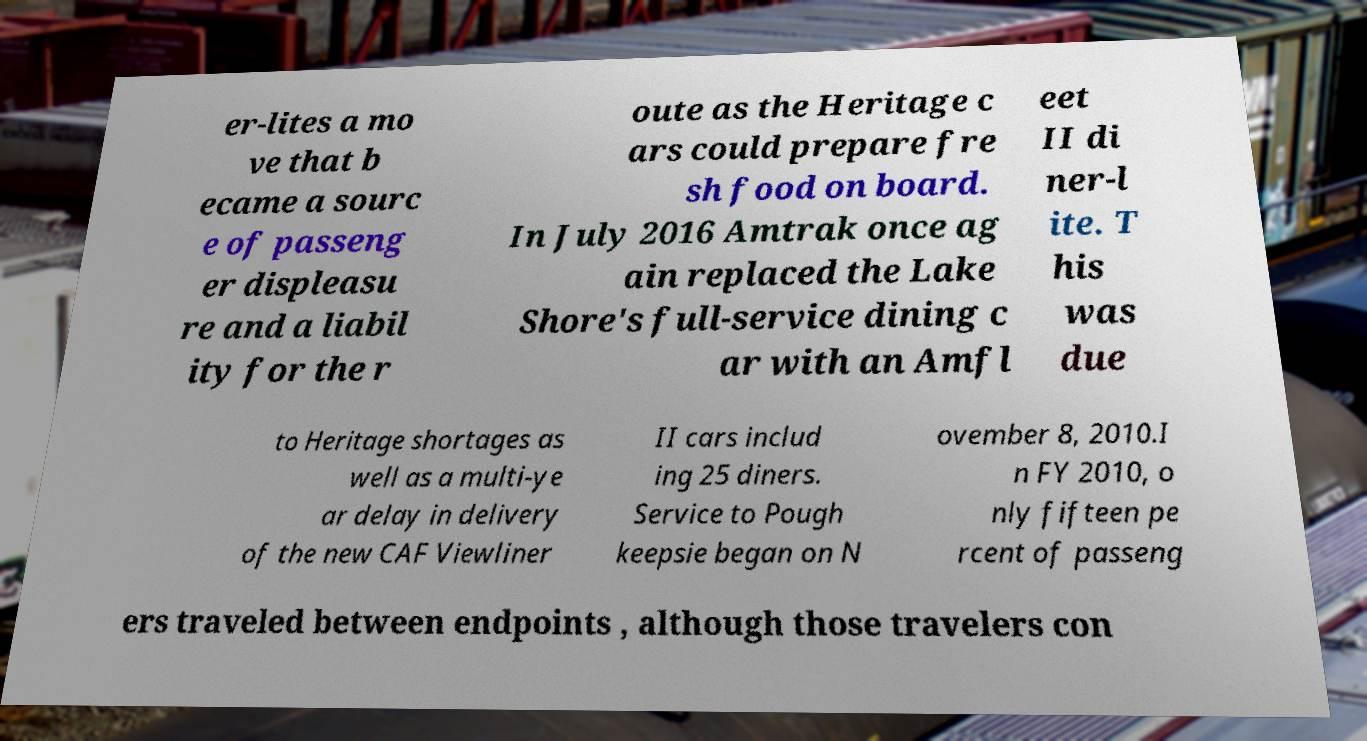Could you extract and type out the text from this image? er-lites a mo ve that b ecame a sourc e of passeng er displeasu re and a liabil ity for the r oute as the Heritage c ars could prepare fre sh food on board. In July 2016 Amtrak once ag ain replaced the Lake Shore's full-service dining c ar with an Amfl eet II di ner-l ite. T his was due to Heritage shortages as well as a multi-ye ar delay in delivery of the new CAF Viewliner II cars includ ing 25 diners. Service to Pough keepsie began on N ovember 8, 2010.I n FY 2010, o nly fifteen pe rcent of passeng ers traveled between endpoints , although those travelers con 